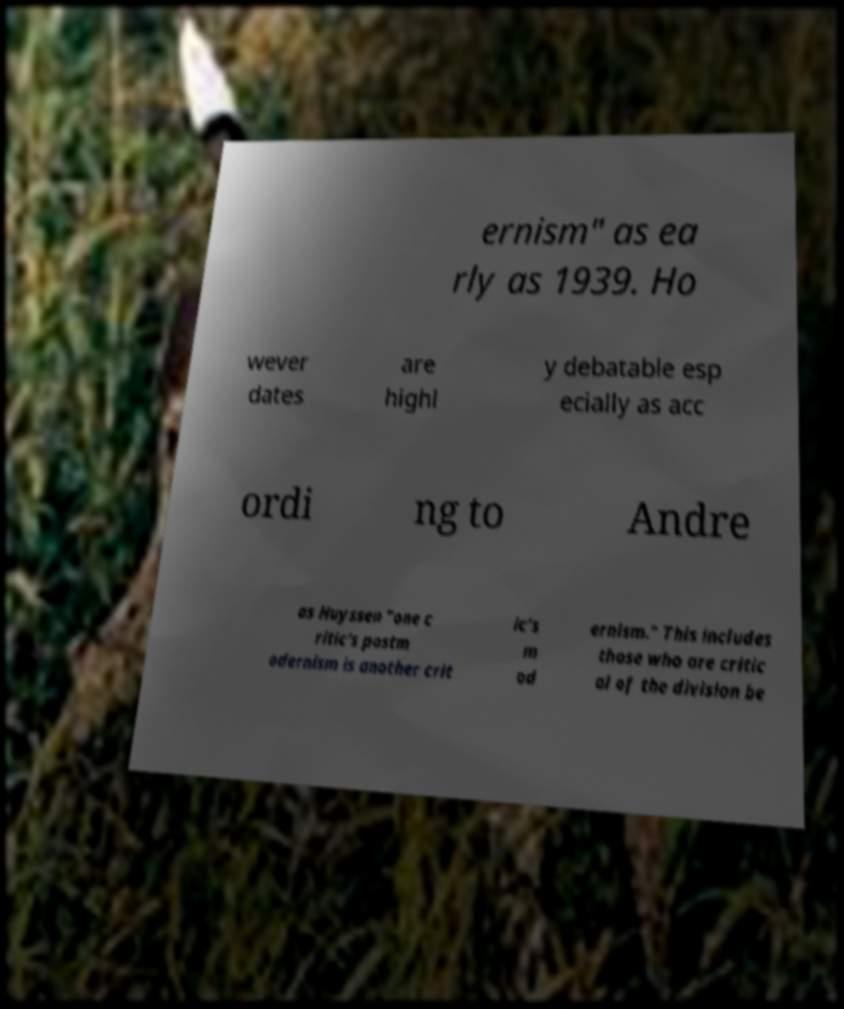Can you accurately transcribe the text from the provided image for me? ernism" as ea rly as 1939. Ho wever dates are highl y debatable esp ecially as acc ordi ng to Andre as Huyssen "one c ritic's postm odernism is another crit ic's m od ernism." This includes those who are critic al of the division be 